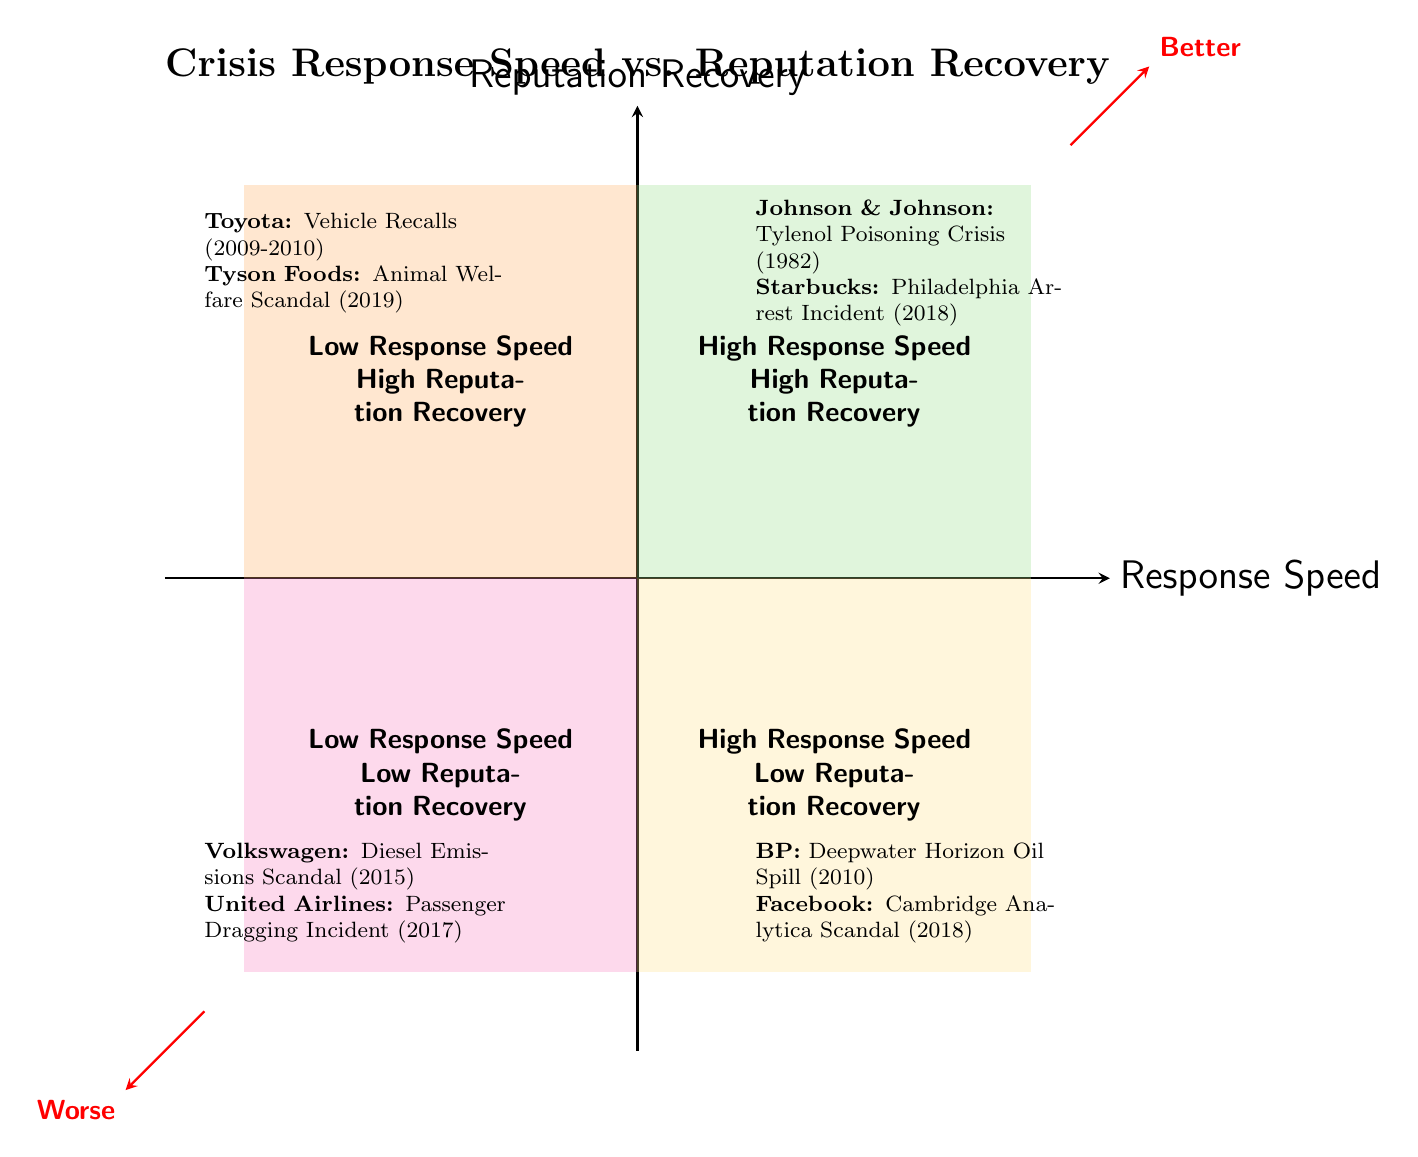What companies are in the High Response Speed-High Reputation Recovery quadrant? The quadrant labeled "High Response Speed-High Reputation Recovery" contains the case studies of Johnson & Johnson and Starbucks. By looking at the top right quadrant, we can see both companies listed under that category.
Answer: Johnson & Johnson, Starbucks How many case studies are in the Low Response Speed-Low Reputation Recovery quadrant? In the "Low Response Speed-Low Reputation Recovery" quadrant, there are two case studies listed: Volkswagen and United Airlines. Therefore, the total count is determined by simply counting the instances listed in this quadrant.
Answer: 2 What incident is associated with BP? BP is associated with the Deepwater Horizon Oil Spill, which is mentioned in the "High Response Speed-Low Reputation Recovery" quadrant. The specific incident is highlighted below BP's name in that quadrant.
Answer: Deepwater Horizon Oil Spill Which company has a high reputation recovery despite a slow response? Toyota is the company that demonstrates high reputation recovery despite a slow initial response during the Vehicle Recalls situation. This is stated in the "Low Response Speed-High Reputation Recovery" quadrant.
Answer: Toyota What was the key action taken by Johnson & Johnson during their crisis? Johnson & Johnson's key actions during the Tylenol Poisoning Crisis included an immediate product recall, transparent communication, and the introduction of tamper-proof packaging. This information is provided in the details of their case study found in the relevant quadrant.
Answer: Immediate product recall, transparent communication, tamper-proof packaging Which quadrant includes companies with both high response speed and low reputation recovery? The quadrant titled "High Response Speed-Low Reputation Recovery" includes the case studies of BP and Facebook, which reflect having responded quickly but struggled to recover reputation. This is evident from the positioning of this quadrant in the lower right section of the chart.
Answer: High Response Speed-Low Reputation Recovery What color represents the Low Response Speed-High Reputation Recovery quadrant? The color assigned to the "Low Response Speed-High Reputation Recovery" quadrant is a light greenish shade, illustrated in the diagram as the background for that quadrant.
Answer: Light greenish shade (quadrant3) Which company had a timely response but faced ongoing trust issues? Facebook had a timely response regarding the Cambridge Analytica Scandal but continued to face ongoing trust issues due to a perceived lack of sufficient long-term changes. This is specified in the description of the case study within the corresponding quadrant.
Answer: Facebook 